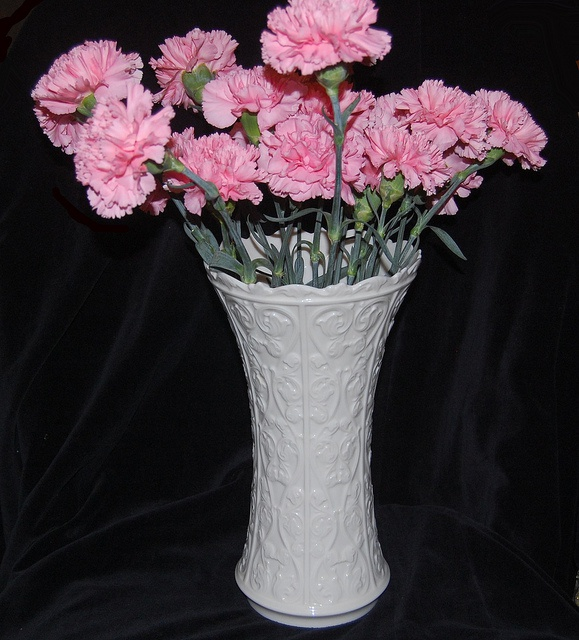Describe the objects in this image and their specific colors. I can see a vase in black, darkgray, gray, and lightgray tones in this image. 